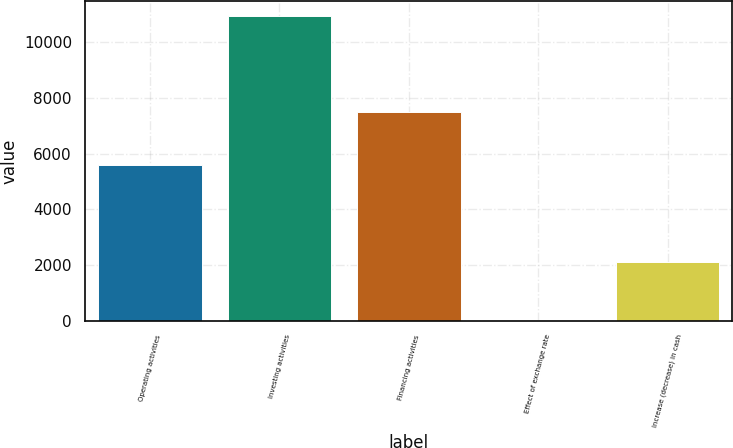Convert chart. <chart><loc_0><loc_0><loc_500><loc_500><bar_chart><fcel>Operating activities<fcel>Investing activities<fcel>Financing activities<fcel>Effect of exchange rate<fcel>Increase (decrease) in cash<nl><fcel>5574<fcel>10916<fcel>7477<fcel>34<fcel>2101<nl></chart> 